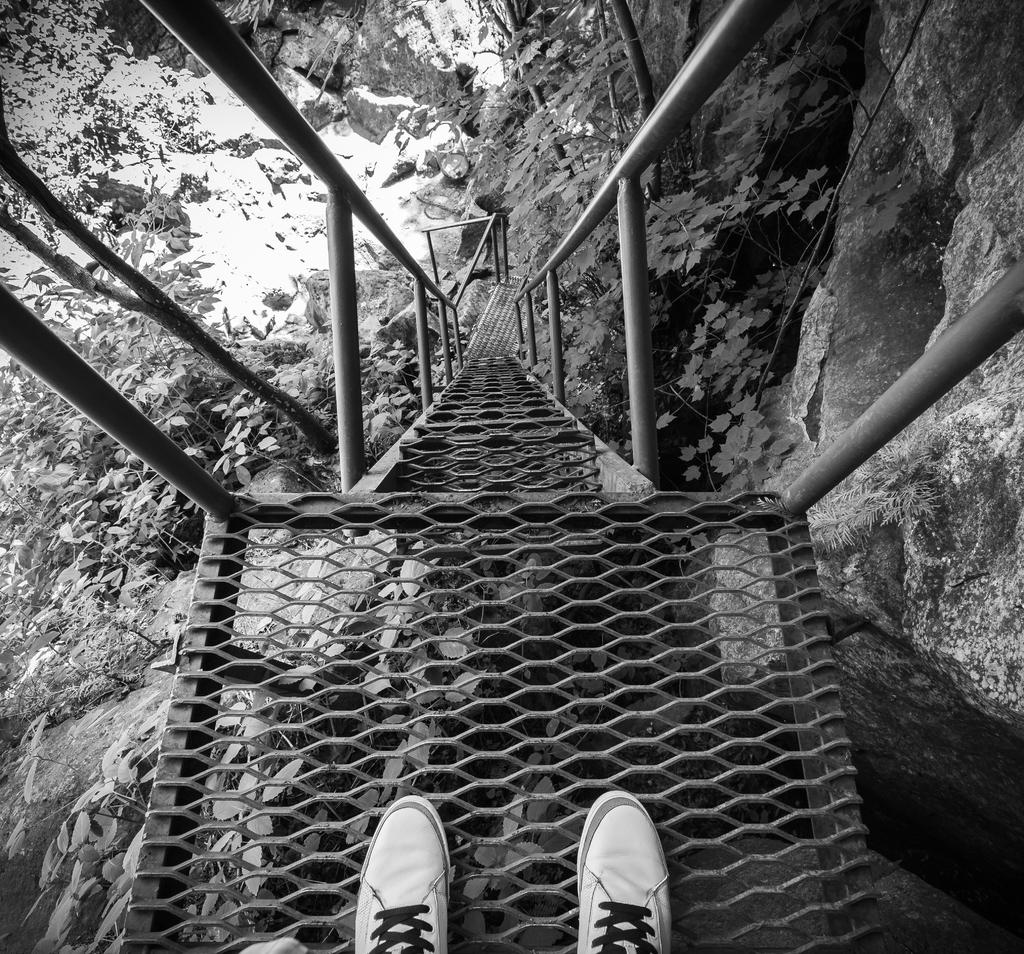What type of footwear is visible in the image? There are white shoes in the image. Where are the shoes placed? The shoes are on mesh stairs. What feature do the stairs have? The stairs have railings. What type of natural elements can be seen in the image? There are plants and rocks in the image. What is the color scheme of the image? The image is black and white. How many cows can be seen grazing near the white shoes in the image? There are no cows present in the image. What type of zebra is visible on the mesh stairs in the image? There is no zebra present in the image. 